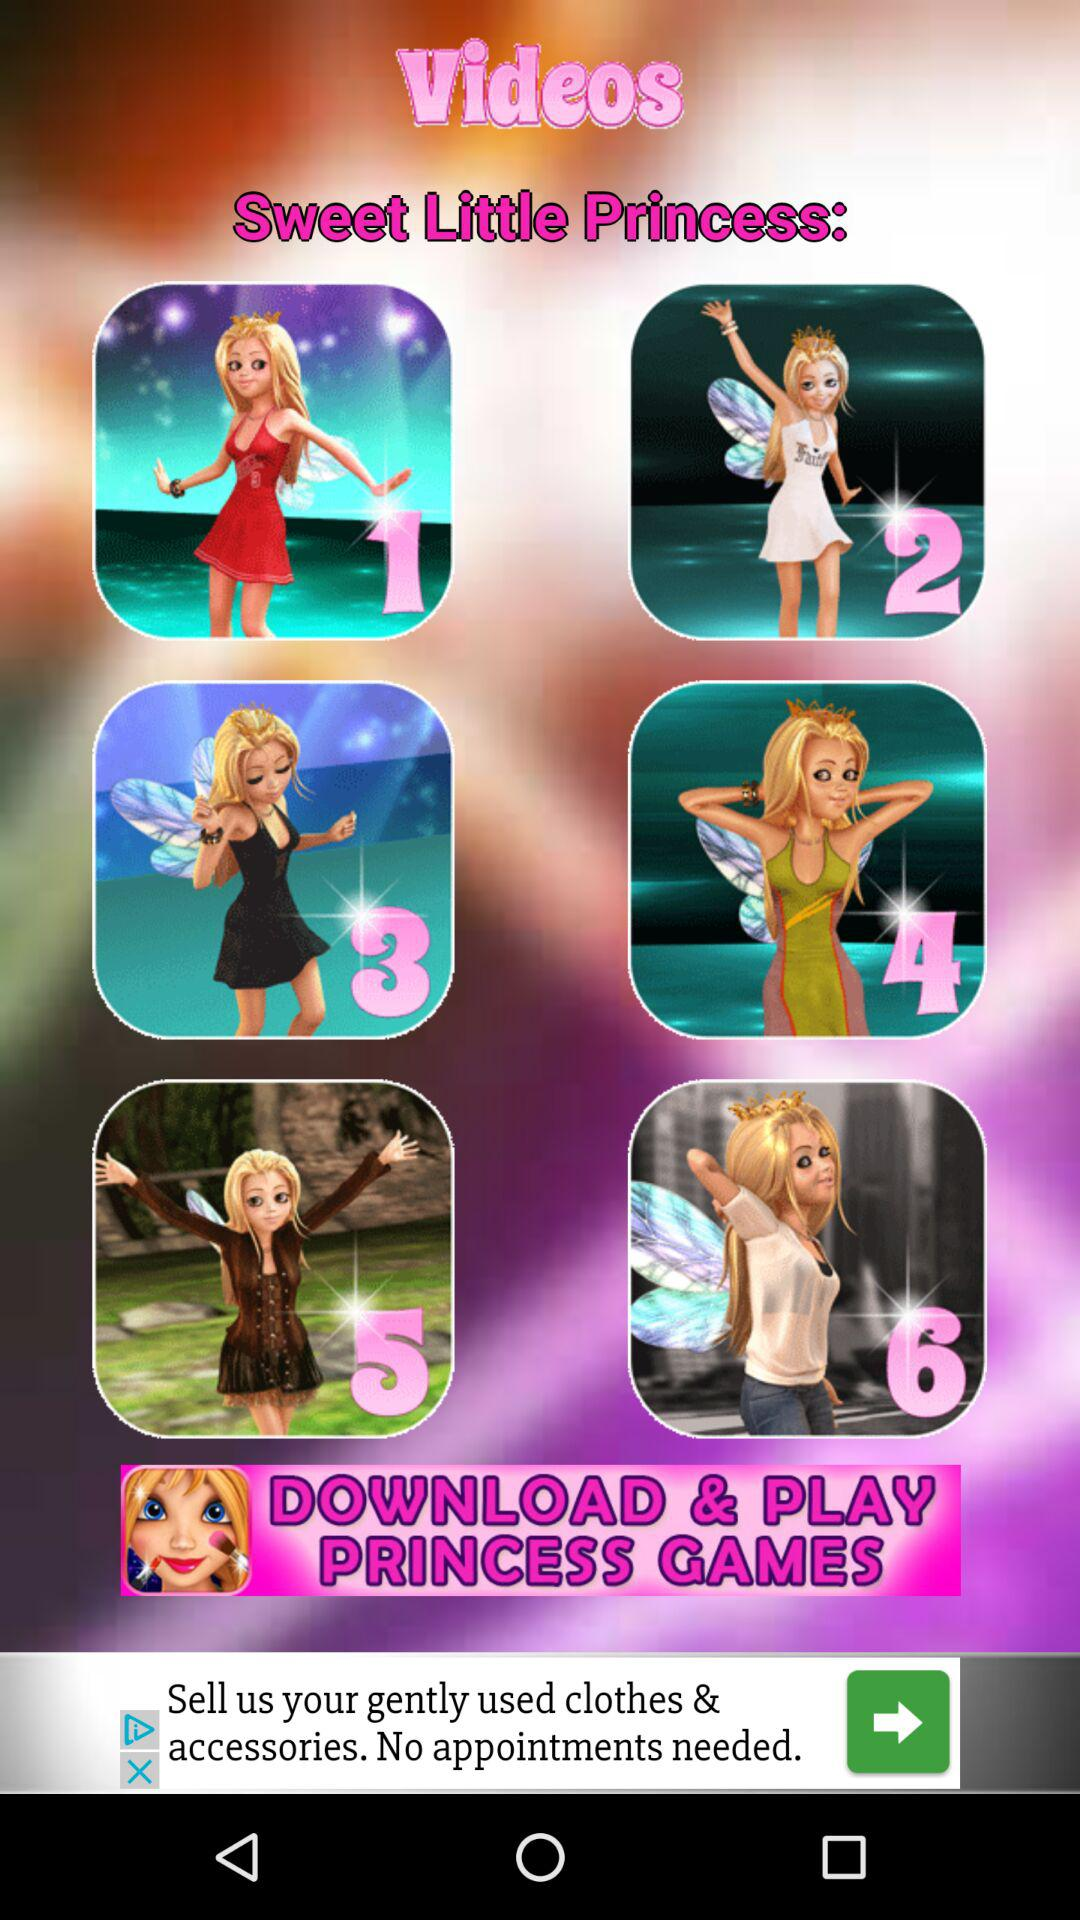Who produced the "Sweet Little Princess" videos?
When the provided information is insufficient, respond with <no answer>. <no answer> 